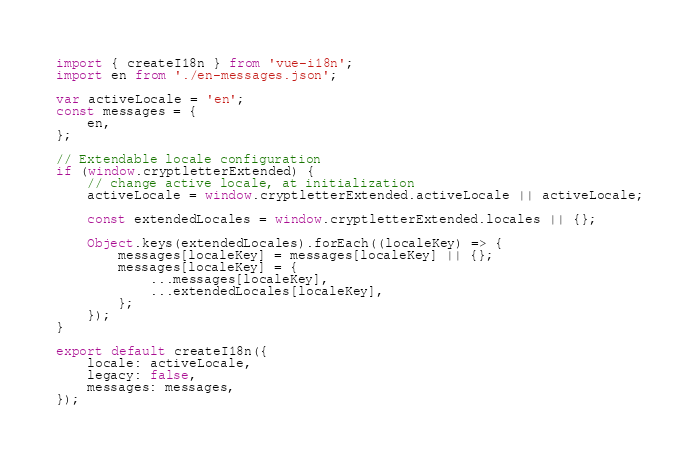<code> <loc_0><loc_0><loc_500><loc_500><_JavaScript_>import { createI18n } from 'vue-i18n';
import en from './en-messages.json';

var activeLocale = 'en';
const messages = {
    en,
};

// Extendable locale configuration
if (window.cryptletterExtended) {
    // change active locale, at initialization
    activeLocale = window.cryptletterExtended.activeLocale || activeLocale;

    const extendedLocales = window.cryptletterExtended.locales || {};

    Object.keys(extendedLocales).forEach((localeKey) => {
        messages[localeKey] = messages[localeKey] || {};
        messages[localeKey] = {
            ...messages[localeKey],
            ...extendedLocales[localeKey],
        };
    });
}

export default createI18n({
    locale: activeLocale,
    legacy: false,
    messages: messages,
});
</code> 